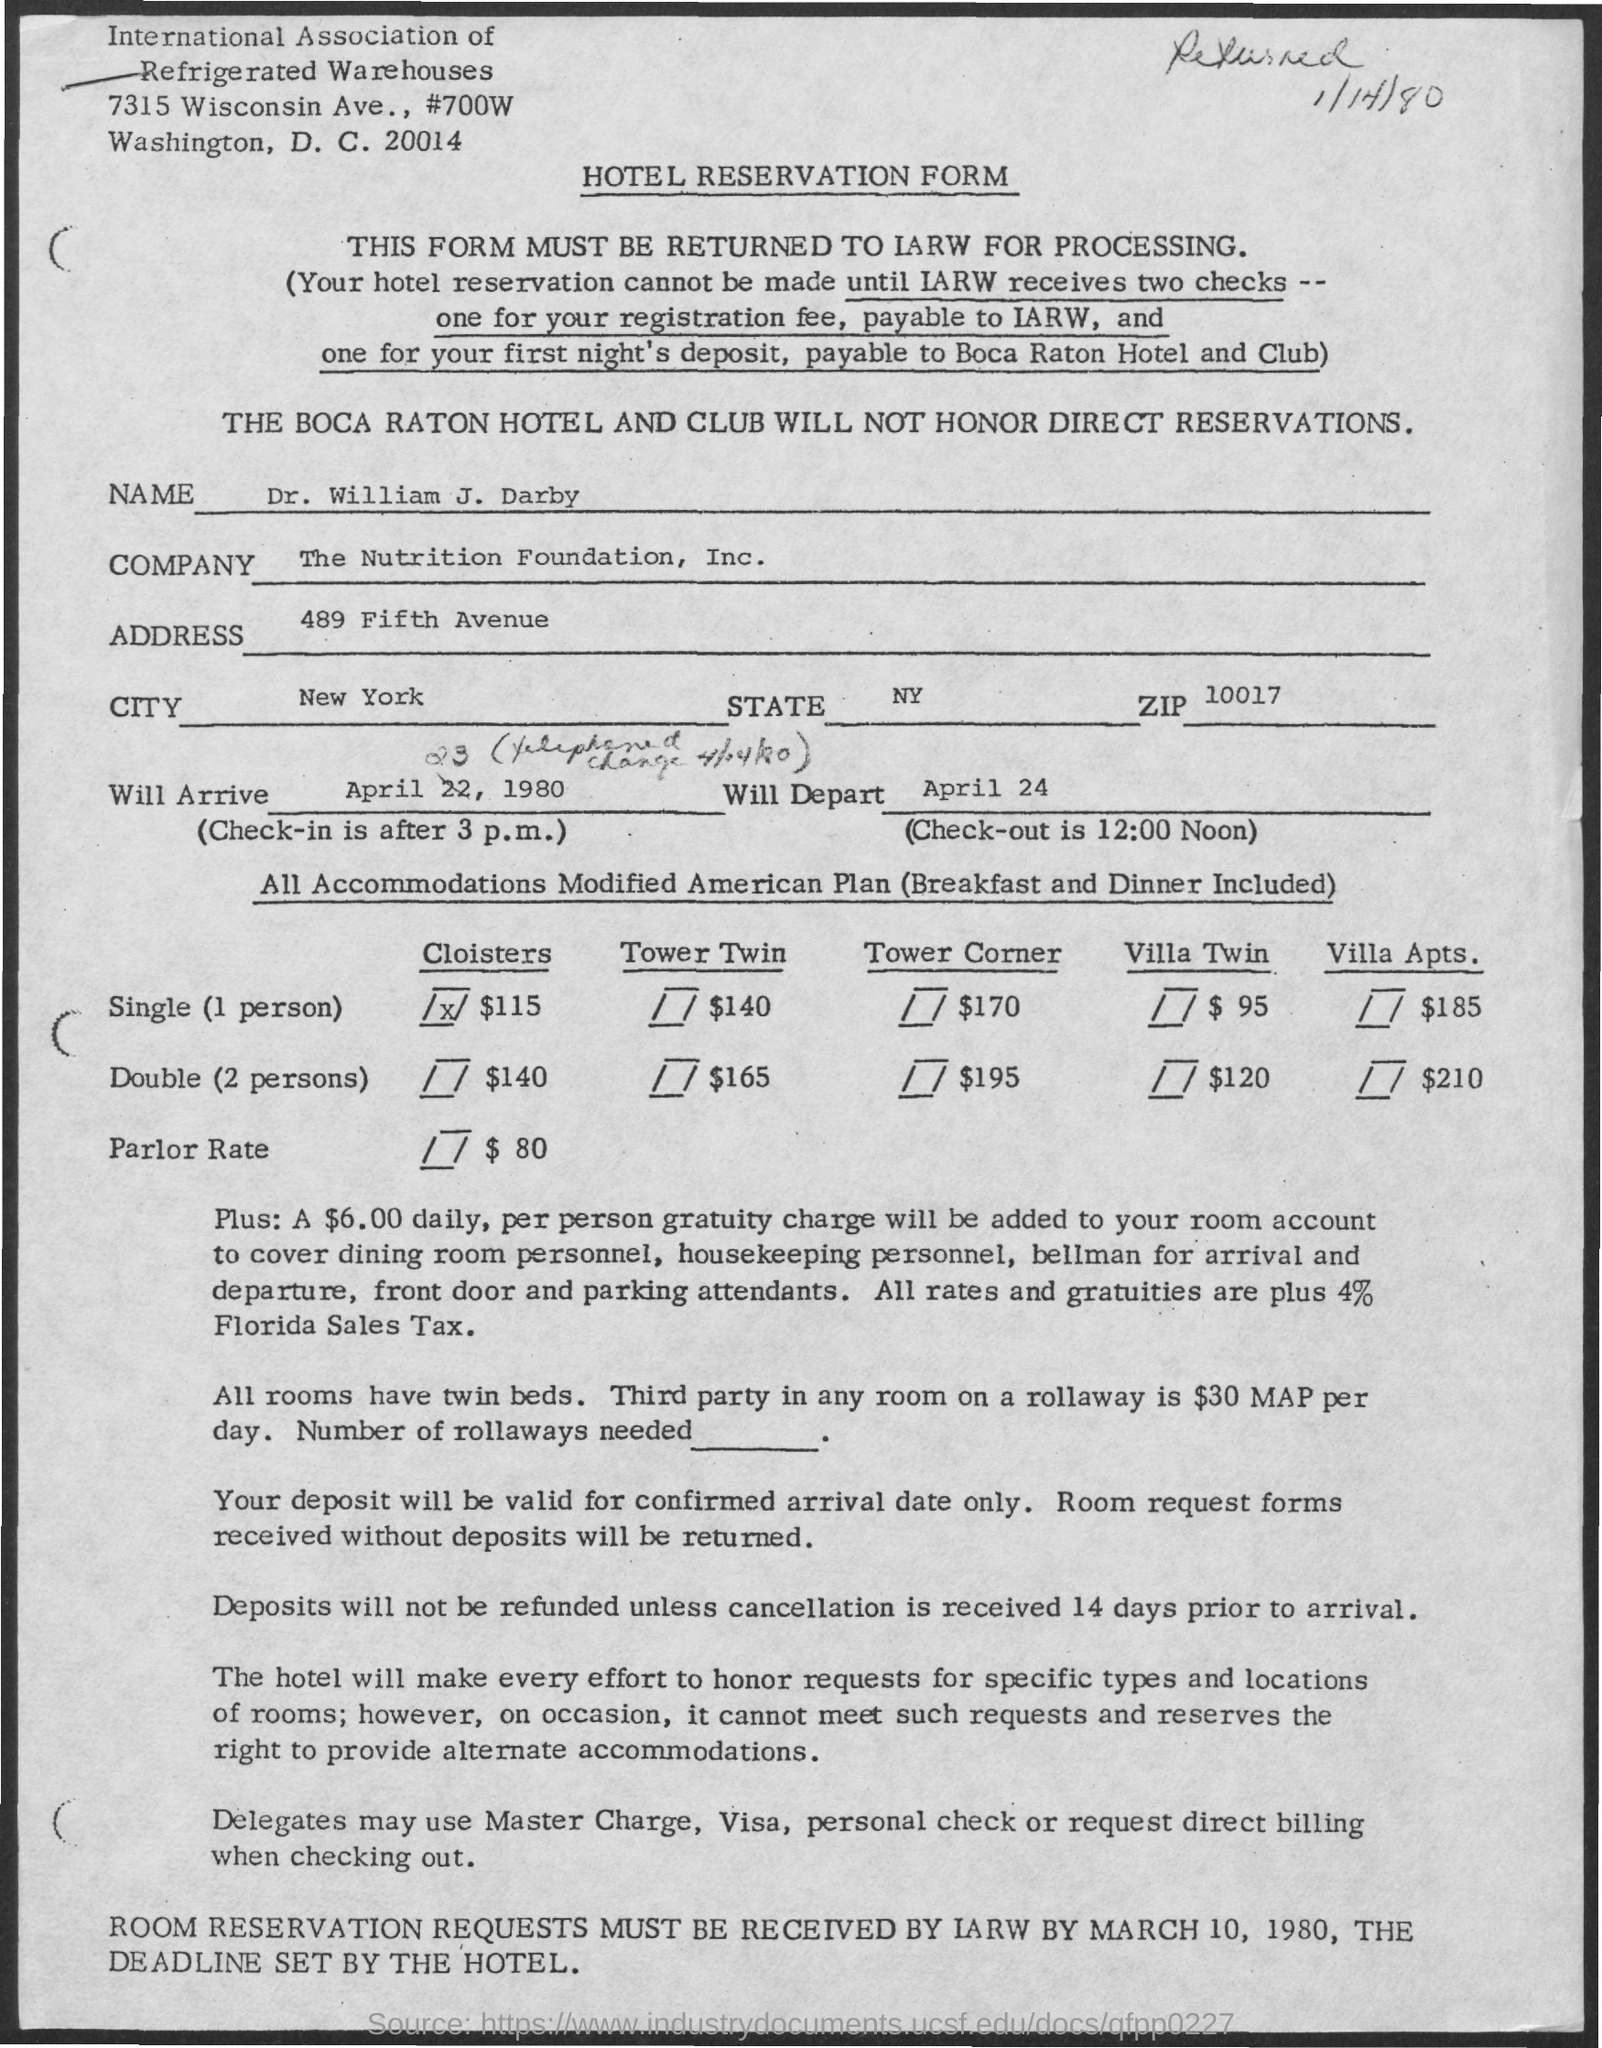Outline some significant characteristics in this image. It is not possible to make reservations at this time as IARW has not received two checks. When will he depart? He is scheduled to leave on April 24th. The state of New York is... The Nutrition Foundation, Inc., commonly known as "The Company," is a non-profit organization dedicated to promoting public awareness and understanding of the role of nutrition in maintaining and improving health. The title of the document is 'Hotel Reservation Form.' 